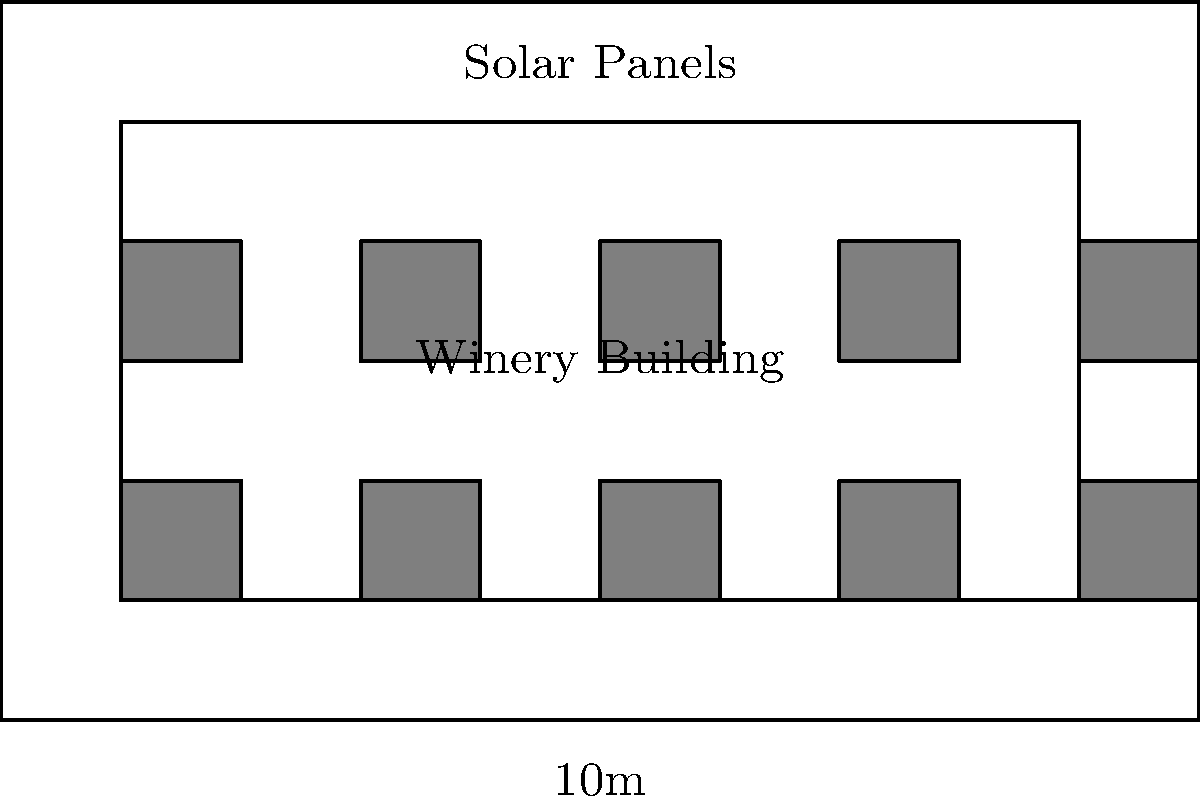A winery owner wants to install solar panels on the roof of their building to power their operations. The roof measures 10m x 6m, and each solar panel is 1m x 1m with an efficiency of 20%. If the winery requires 15 kWh of energy per day and receives an average of 5 hours of peak sunlight, how many solar panels should be installed to meet the energy needs?

Assume:
1. Solar irradiance: 1000 W/m²
2. No spacing between panels
3. All panels receive equal sunlight To solve this problem, we'll follow these steps:

1. Calculate the energy produced by one solar panel per day:
   Panel area = 1m² × 1m² = 1m²
   Energy received = 1000 W/m² × 1m² × 5 hours = 5000 Wh = 5 kWh
   Energy produced = 5 kWh × 20% efficiency = 1 kWh per panel per day

2. Calculate the number of panels needed:
   Energy required = 15 kWh per day
   Number of panels = Energy required ÷ Energy per panel
   Number of panels = 15 kWh ÷ 1 kWh = 15 panels

3. Check if the roof can accommodate the panels:
   Roof area = 10m × 6m = 60m²
   Panel area = 1m² per panel
   Maximum panels possible = 60m² ÷ 1m² = 60 panels

The roof can accommodate the required 15 panels.

Therefore, the winery should install 15 solar panels to meet their energy needs.
Answer: 15 solar panels 